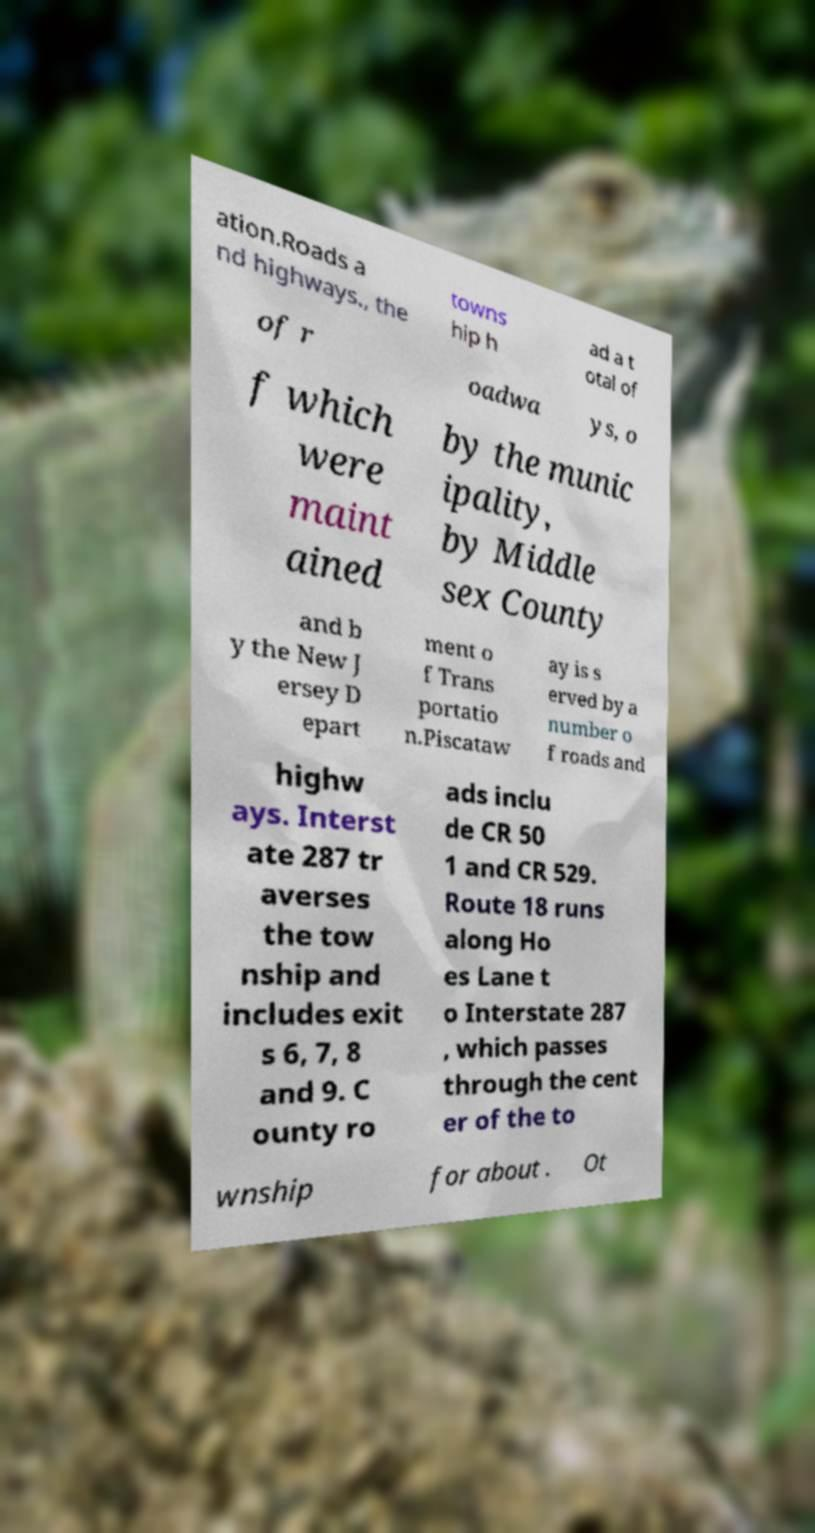Please read and relay the text visible in this image. What does it say? ation.Roads a nd highways., the towns hip h ad a t otal of of r oadwa ys, o f which were maint ained by the munic ipality, by Middle sex County and b y the New J ersey D epart ment o f Trans portatio n.Piscataw ay is s erved by a number o f roads and highw ays. Interst ate 287 tr averses the tow nship and includes exit s 6, 7, 8 and 9. C ounty ro ads inclu de CR 50 1 and CR 529. Route 18 runs along Ho es Lane t o Interstate 287 , which passes through the cent er of the to wnship for about . Ot 